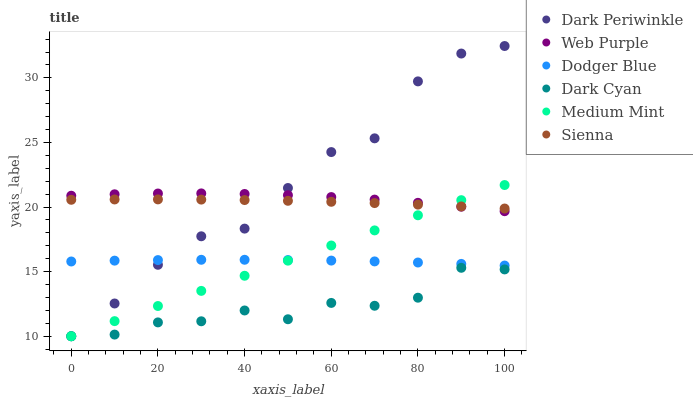Does Dark Cyan have the minimum area under the curve?
Answer yes or no. Yes. Does Dark Periwinkle have the maximum area under the curve?
Answer yes or no. Yes. Does Sienna have the minimum area under the curve?
Answer yes or no. No. Does Sienna have the maximum area under the curve?
Answer yes or no. No. Is Medium Mint the smoothest?
Answer yes or no. Yes. Is Dark Periwinkle the roughest?
Answer yes or no. Yes. Is Sienna the smoothest?
Answer yes or no. No. Is Sienna the roughest?
Answer yes or no. No. Does Medium Mint have the lowest value?
Answer yes or no. Yes. Does Web Purple have the lowest value?
Answer yes or no. No. Does Dark Periwinkle have the highest value?
Answer yes or no. Yes. Does Sienna have the highest value?
Answer yes or no. No. Is Dodger Blue less than Sienna?
Answer yes or no. Yes. Is Sienna greater than Dark Cyan?
Answer yes or no. Yes. Does Dodger Blue intersect Dark Periwinkle?
Answer yes or no. Yes. Is Dodger Blue less than Dark Periwinkle?
Answer yes or no. No. Is Dodger Blue greater than Dark Periwinkle?
Answer yes or no. No. Does Dodger Blue intersect Sienna?
Answer yes or no. No. 